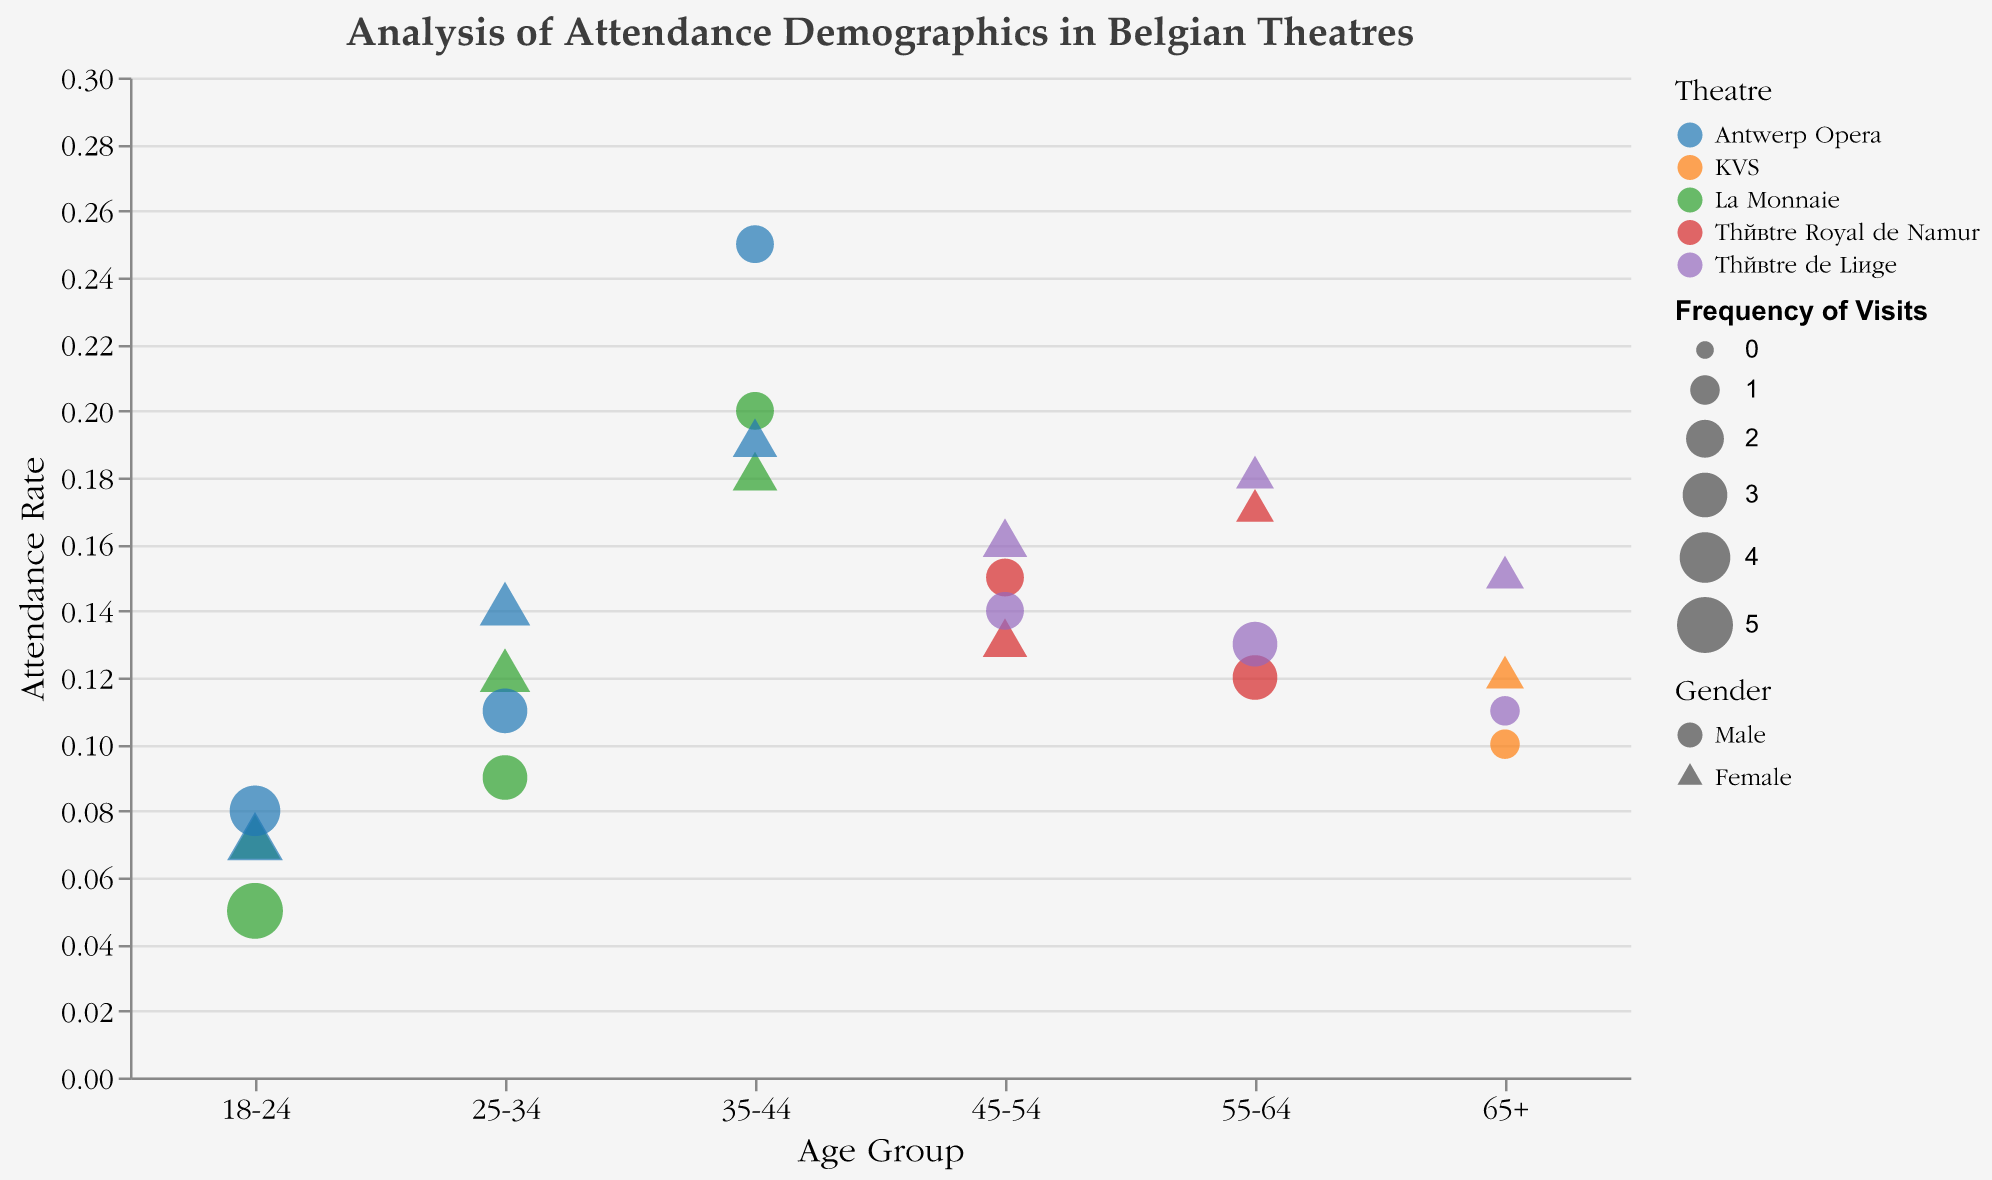What is the title of the chart? The title is located at the top of the chart and reads "Analysis of Attendance Demographics in Belgian Theatres".
Answer: Analysis of Attendance Demographics in Belgian Theatres Which age group has the highest attendance rate at Antwerp Opera? To find this, look at the "Age Group" categories and identify the "Antwerp Opera" attendance rates. The highest rate comes from the 35-44 age group with a rate of 0.25.
Answer: 35-44 How does the attendance rate for females aged 25-34 differ between La Monnaie and Antwerp Opera? Check the attendance rates for females aged 25-34 at La Monnaie (0.12) and Antwerp Opera (0.14). Subtract the former from the latter to find the difference.
Answer: 0.02 Which theatre has the most frequent visits from males aged 18-24? Look for "Male", "18-24", and check the "Frequency of Visits". La Monnaie has the highest frequency for this group with 5 visits.
Answer: La Monnaie What is the general trend of attendance rates as age increases for Théâtre de Liège? Evaluate the "Attendance Rate" column for each age group at Théâtre de Liège. The rates generally show a slight increase from younger age groups to older age groups.
Answer: Increase Compare the attendance rates for males and females aged 45-54 at Théâtre Royal de Namur. Locate the values for males (0.15) and females (0.13) aged 45-54 at Théâtre Royal de Namur. Males have a higher attendance rate.
Answer: Males have a higher rate What is the average attendance rate for attendees aged 55-64 at Théâtre de Liège? Add the attendance rates for males (0.13) and females (0.18) aged 55-64 at Théâtre de Liège and divide by 2. (0.13 + 0.18) / 2 gives an average of 0.155.
Answer: 0.155 Which gender and age group combination has the lowest frequency of visits at KVS? Look at the "Frequency of Visits" at KVS for each age group and gender. The lowest frequency is for males aged 65+ with 1 visit.
Answer: Male, 65+ How does the number of frequent visits vary between genders for the 25-34 age group at La Monnaie? Check the "Frequency of Visits" for males (3) and females (4) aged 25-34 at La Monnaie. Females visit more frequently.
Answer: Females visit more frequently 